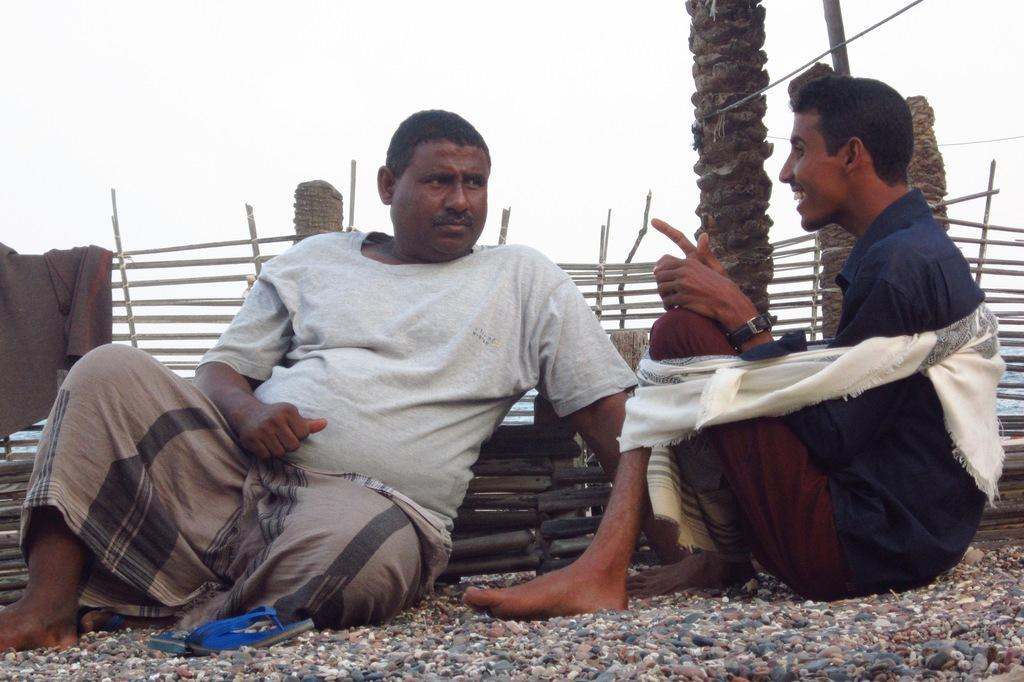How many people are in the image? There are two persons in the image. Where are the persons located in the image? The persons are sitting in the center of the image. What can be seen at the bottom of the image? There are stones at the bottom of the image. What type of reaction can be seen from the geese in the image? There are no geese present in the image, so it is not possible to determine their reaction. 